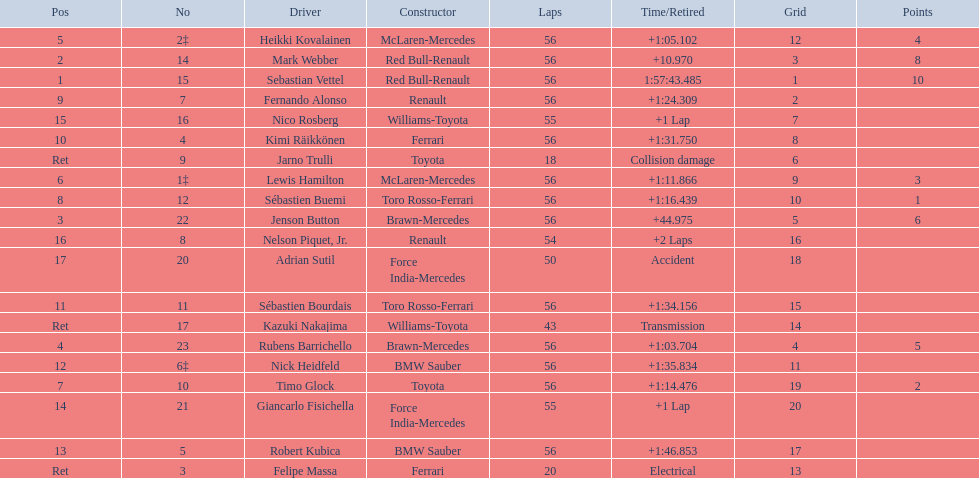Why did the  toyota retire Collision damage. What was the drivers name? Jarno Trulli. 